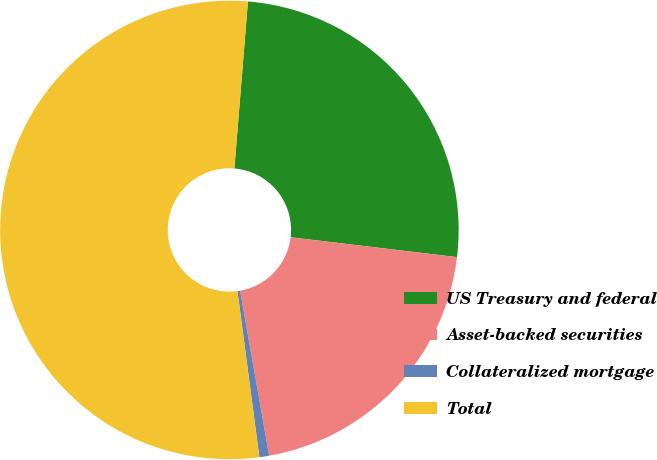Convert chart. <chart><loc_0><loc_0><loc_500><loc_500><pie_chart><fcel>US Treasury and federal<fcel>Asset-backed securities<fcel>Collateralized mortgage<fcel>Total<nl><fcel>25.6%<fcel>20.33%<fcel>0.69%<fcel>53.37%<nl></chart> 